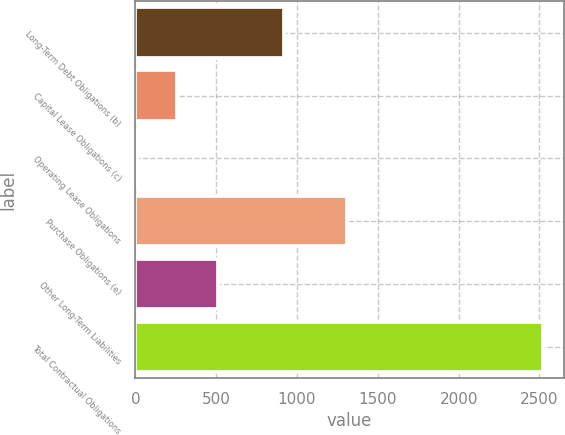<chart> <loc_0><loc_0><loc_500><loc_500><bar_chart><fcel>Long-Term Debt Obligations (b)<fcel>Capital Lease Obligations (c)<fcel>Operating Lease Obligations<fcel>Purchase Obligations (e)<fcel>Other Long-Term Liabilities<fcel>Total Contractual Obligations<nl><fcel>917.8<fcel>259.12<fcel>7.6<fcel>1309.4<fcel>510.64<fcel>2522.8<nl></chart> 